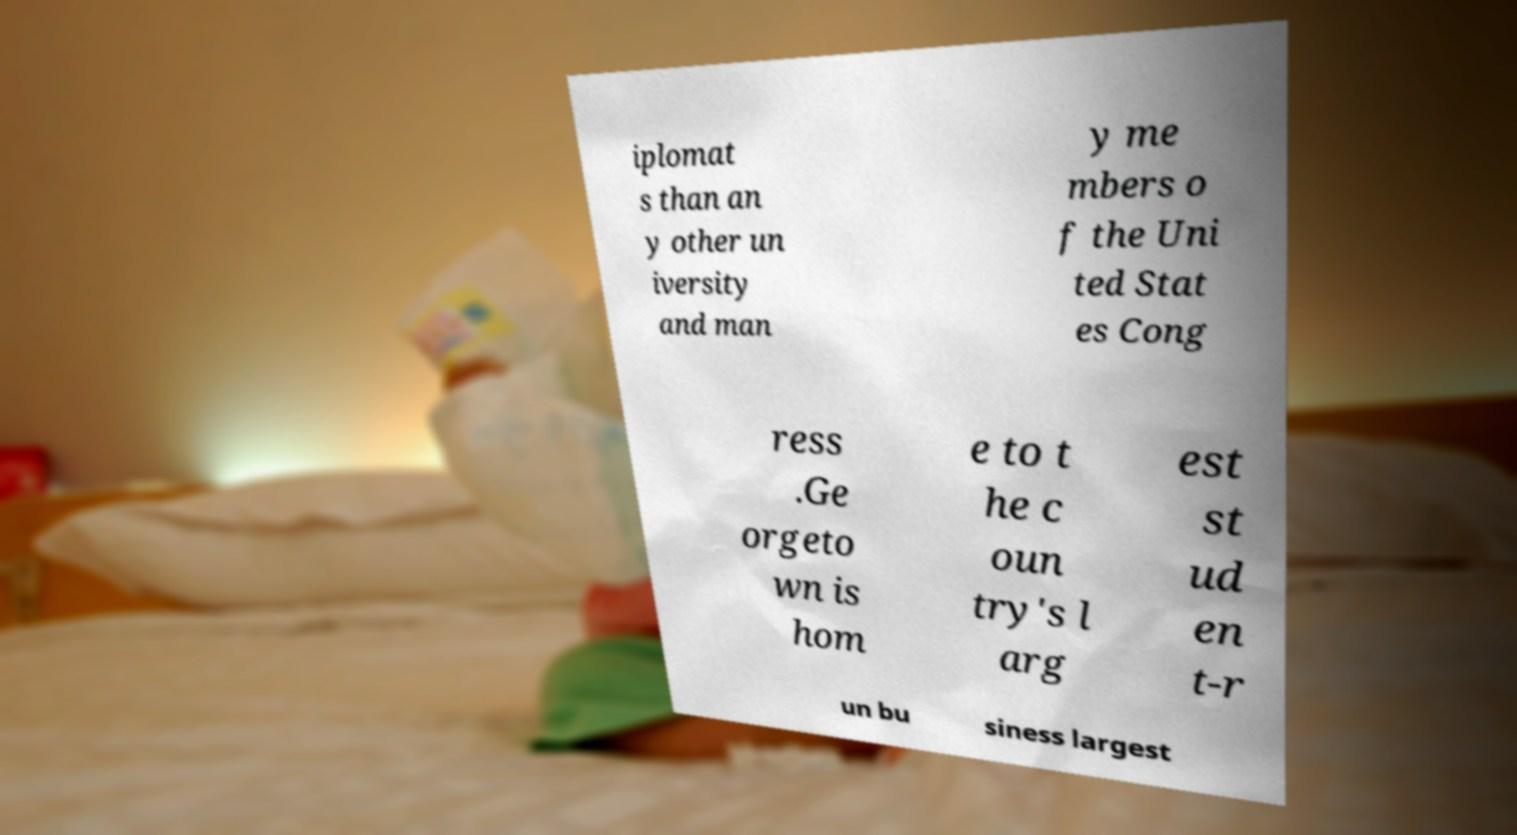Could you extract and type out the text from this image? iplomat s than an y other un iversity and man y me mbers o f the Uni ted Stat es Cong ress .Ge orgeto wn is hom e to t he c oun try's l arg est st ud en t-r un bu siness largest 